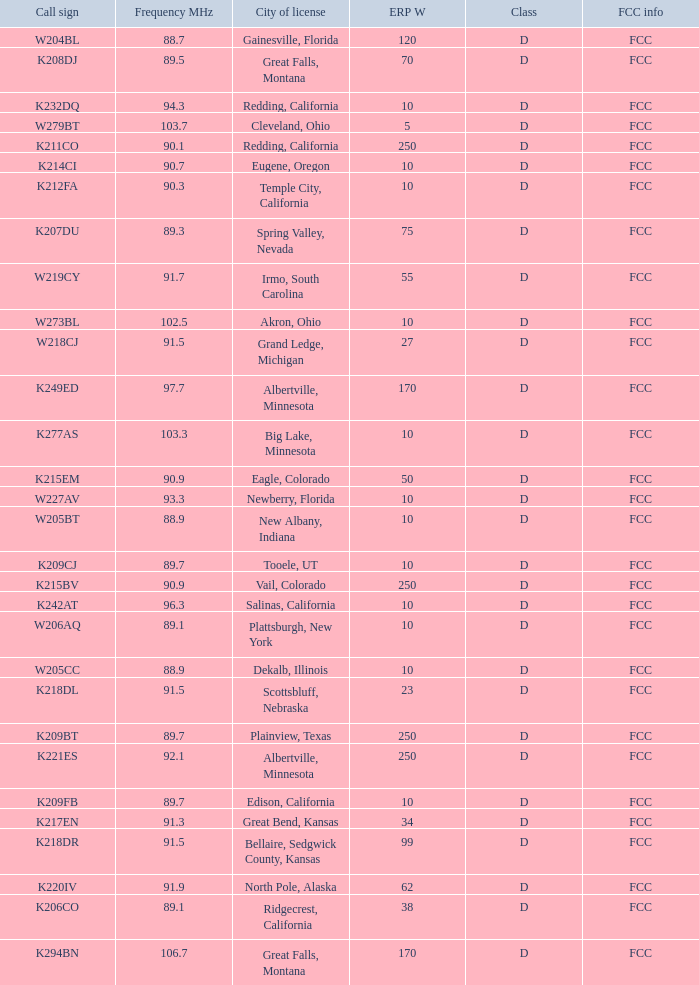What is the highest ERP W of an 89.1 frequency translator? 38.0. 